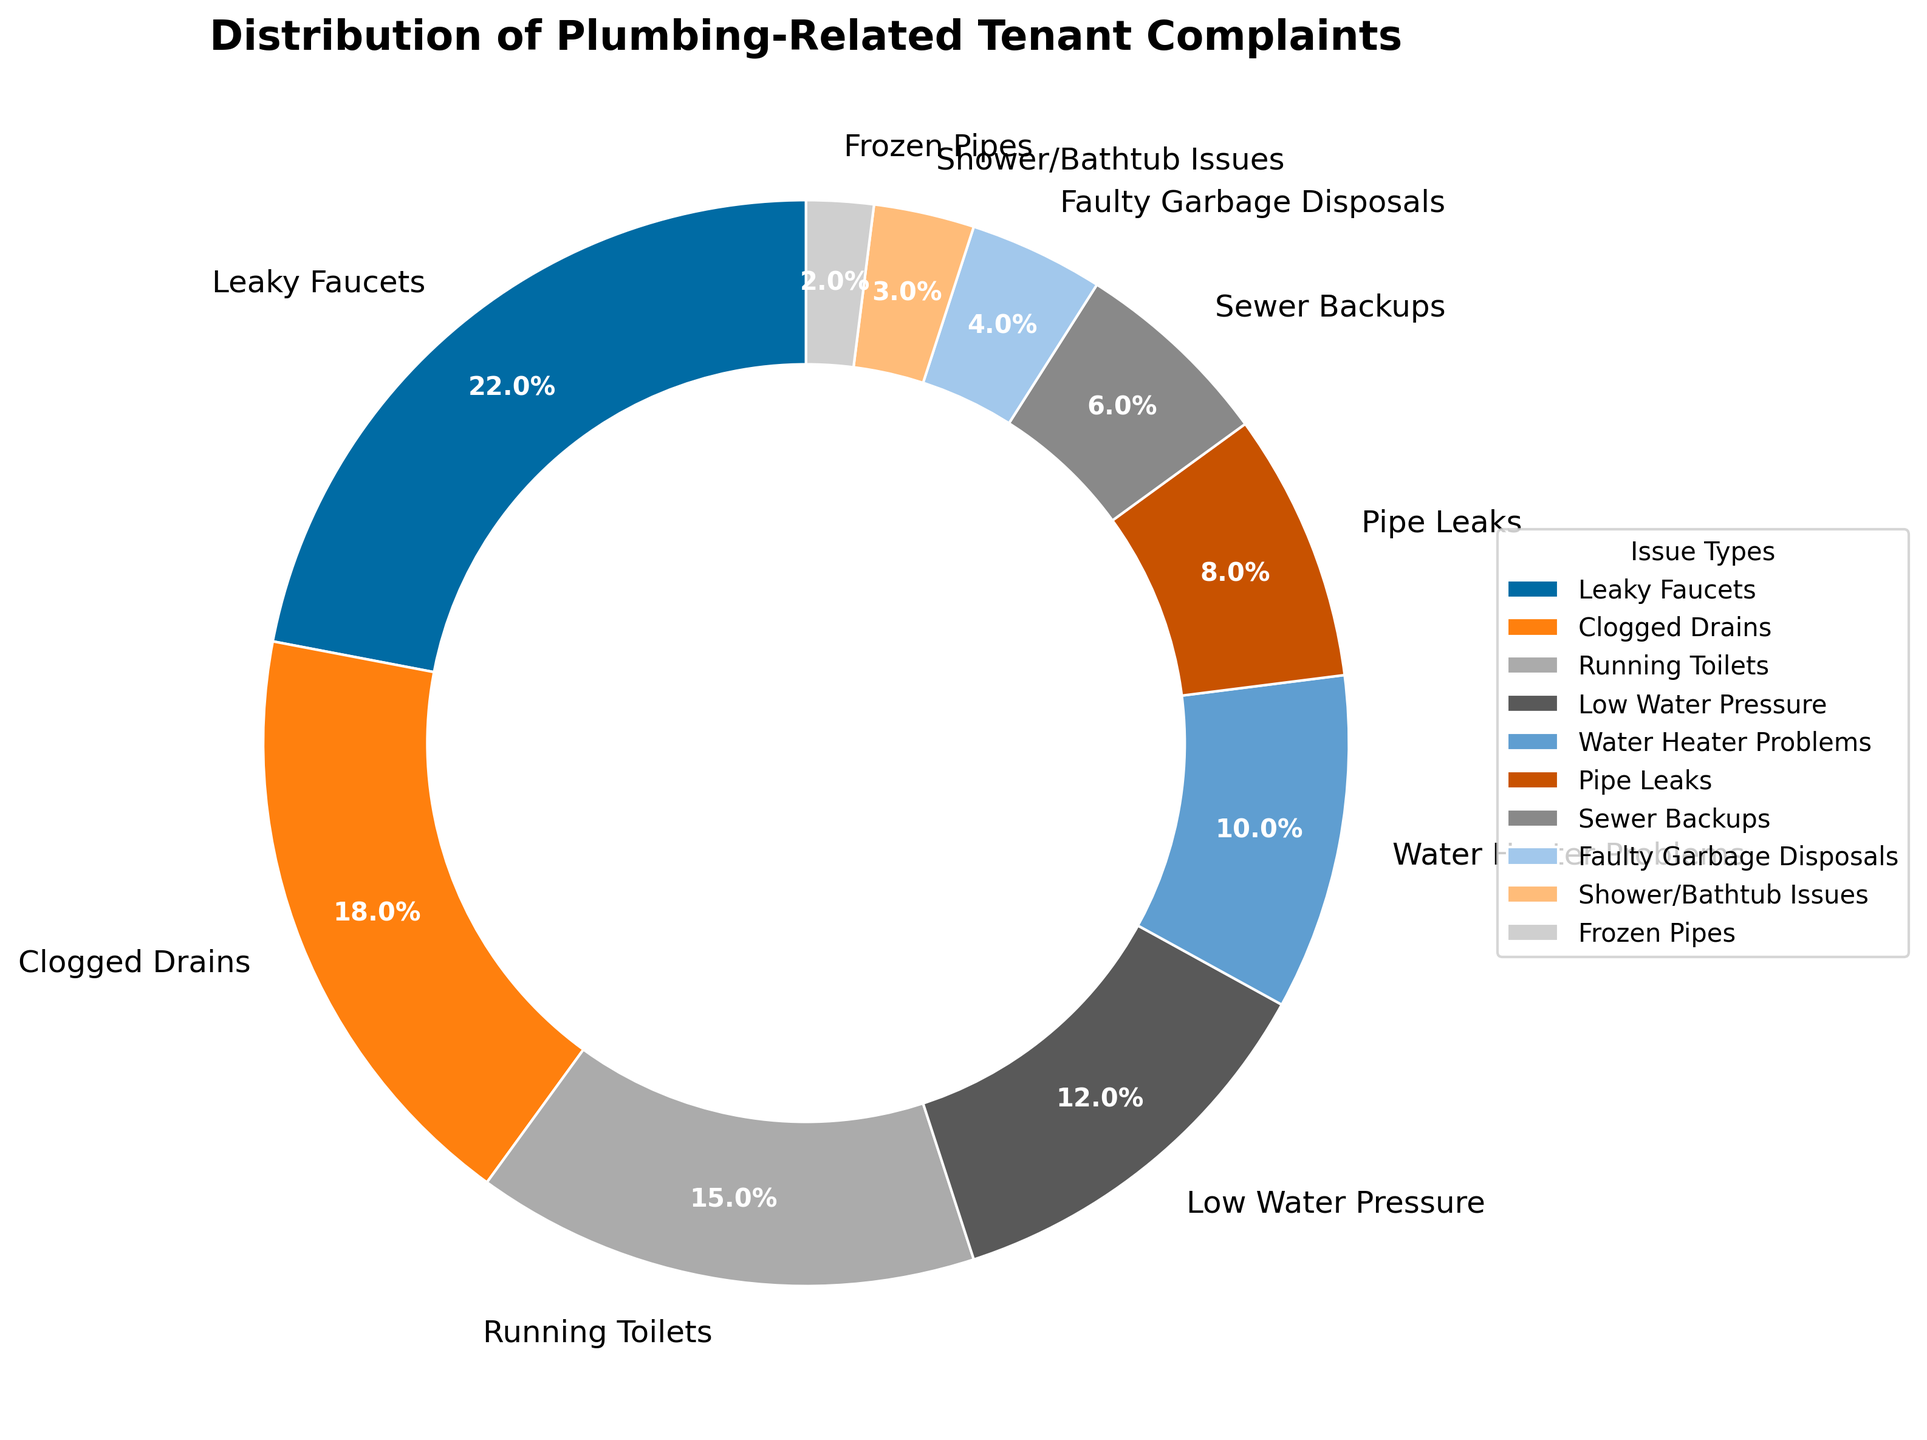Which issue type has the highest percentage of tenant complaints? The pie chart shows different issue types labeled with their corresponding percentages. To find the issue type with the highest percentage, look for the largest slice of the pie chart.
Answer: Leaky Faucets What is the combined percentage of complaints related to Leaky Faucets and Clogged Drains? Identify the percentages for Leaky Faucets and Clogged Drains from the chart, which are 22% and 18% respectively. Add them together: 22% + 18% = 40%.
Answer: 40% Which issue type has fewer complaints: Water Heater Problems or Running Toilets? Compare the percentages of the slices labeled as Water Heater Problems and Running Toilets. Water Heater Problems has 10% and Running Toilets has 15%. Therefore, Water Heater Problems has fewer complaints.
Answer: Water Heater Problems How does the percentage of Sewer Backups complaints compare to that of Pipe Leaks? From the pie chart, find the percentages for Sewer Backups and Pipe Leaks. Sewer Backups are 6%, while Pipe Leaks are 8%. Sewer Backups have a lower percentage than Pipe Leaks.
Answer: Sewer Backups are less than Pipe Leaks What's the difference in the percentage of complaints between Low Water Pressure and Frozen Pipes? Locate the percentages for Low Water Pressure and Frozen Pipes on the chart. Low Water Pressure is 12% and Frozen Pipes is 2%. Subtract the smaller percentage from the larger one: 12% - 2% = 10%.
Answer: 10% If the percentages of Low Water Pressure and Pipe Leaks are combined, do they exceed the percentage of Leaky Faucets? First, add the percentages of Low Water Pressure and Pipe Leaks: 12% + 8% = 20%. Compare this combined percentage to Leaky Faucets’ percentage, which is 22%. 20% is less than 22%, so they do not exceed.
Answer: No Which two smallest issue types combined equal the percentage of Running Toilets? Identify the smallest percentages on the pie chart: Frozen Pipes (2%) and Shower/Bathtub Issues (3%). Their combined percentage is 2% + 3% = 5%, which is not equal to Running Toilets' 15%. Next smallest is Faulty Garbage Disposals with 4%. Combined percentage of Frozen Pipes and Faulty Garbage Disposals is 2% + 4% = 6%, also not equal. Then, Shower/Bathtub Issues and Faulty Garbage Disposals get a combined 3% + 4% = 7%, again not equal. Therefore, no such pair equals 15%.
Answer: None What is the total percentage of complaints for the three smallest issue types? From the pie chart, identify the three issue types with the smallest percentages: Frozen Pipes (2%), Shower/Bathtub Issues (3%), and Faulty Garbage Disposals (4%). Add these percentages: 2% + 3% + 4% = 9%.
Answer: 9% By how much does the percentage of Clogged Drains complaints exceed Sewer Backups complaints? Find the percentages for Clogged Drains (18%) and Sewer Backups (6%) on the pie chart. Subtract the smaller percentage from the larger one: 18% - 6% = 12%.
Answer: 12% 